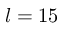Convert formula to latex. <formula><loc_0><loc_0><loc_500><loc_500>l = 1 5</formula> 